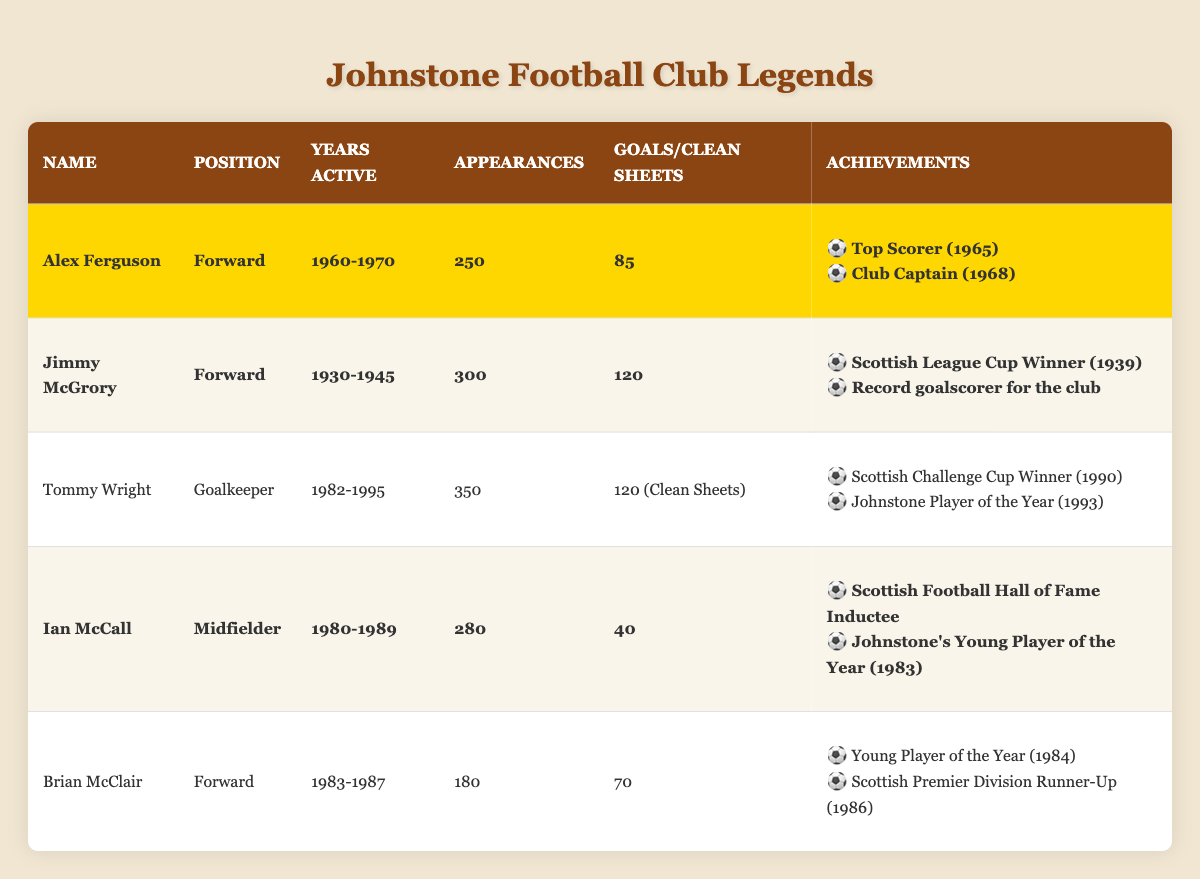What position did Jimmy McGrory play? The table states that Jimmy McGrory's position is listed as Forward.
Answer: Forward How many appearances did Tommy Wright have? According to the table, Tommy Wright had a total of 350 appearances.
Answer: 350 Who has the most goals for Johnstone Football Club? The table indicates that Jimmy McGrory scored 120 goals, which is the highest number compared to others.
Answer: Jimmy McGrory What are the achievements of Alex Ferguson? Looking under Alex Ferguson's achievements, the list includes "Top Scorer (1965)" and "Club Captain (1968)."
Answer: Top Scorer (1965), Club Captain (1968) Which player had the most years active at Johnstone Football Club? Tommy Wright was active from 1982 to 1995, totaling 13 years, which is more than any other player listed.
Answer: Tommy Wright How many goals in total did Ian McCall and Brian McClair score? Ian McCall scored 40 goals and Brian McClair scored 70 goals. Adding these together gives 40 + 70 = 110.
Answer: 110 Did any player achieve both a top scorer title and club captaincy? The table shows that Alex Ferguson achieved both titles: Top Scorer (1965) and Club Captain (1968).
Answer: Yes Which player's achievements include being inducted into the Scottish Football Hall of Fame? The table states that Ian McCall is noted as a Scottish Football Hall of Fame Inductee.
Answer: Ian McCall What is the average number of goals scored by the highlighted players? The highlighted players scored: Alex Ferguson (85), Jimmy McGrory (120), and Ian McCall (40). The sum is 85 + 120 + 40 = 245, and there are 3 players, so the average is 245 / 3 = 81.67.
Answer: 81.67 Was Jimmy McGrory a goalkeeper? The table indicates that Jimmy McGrory's position is listed as Forward, not goalkeeper.
Answer: No 